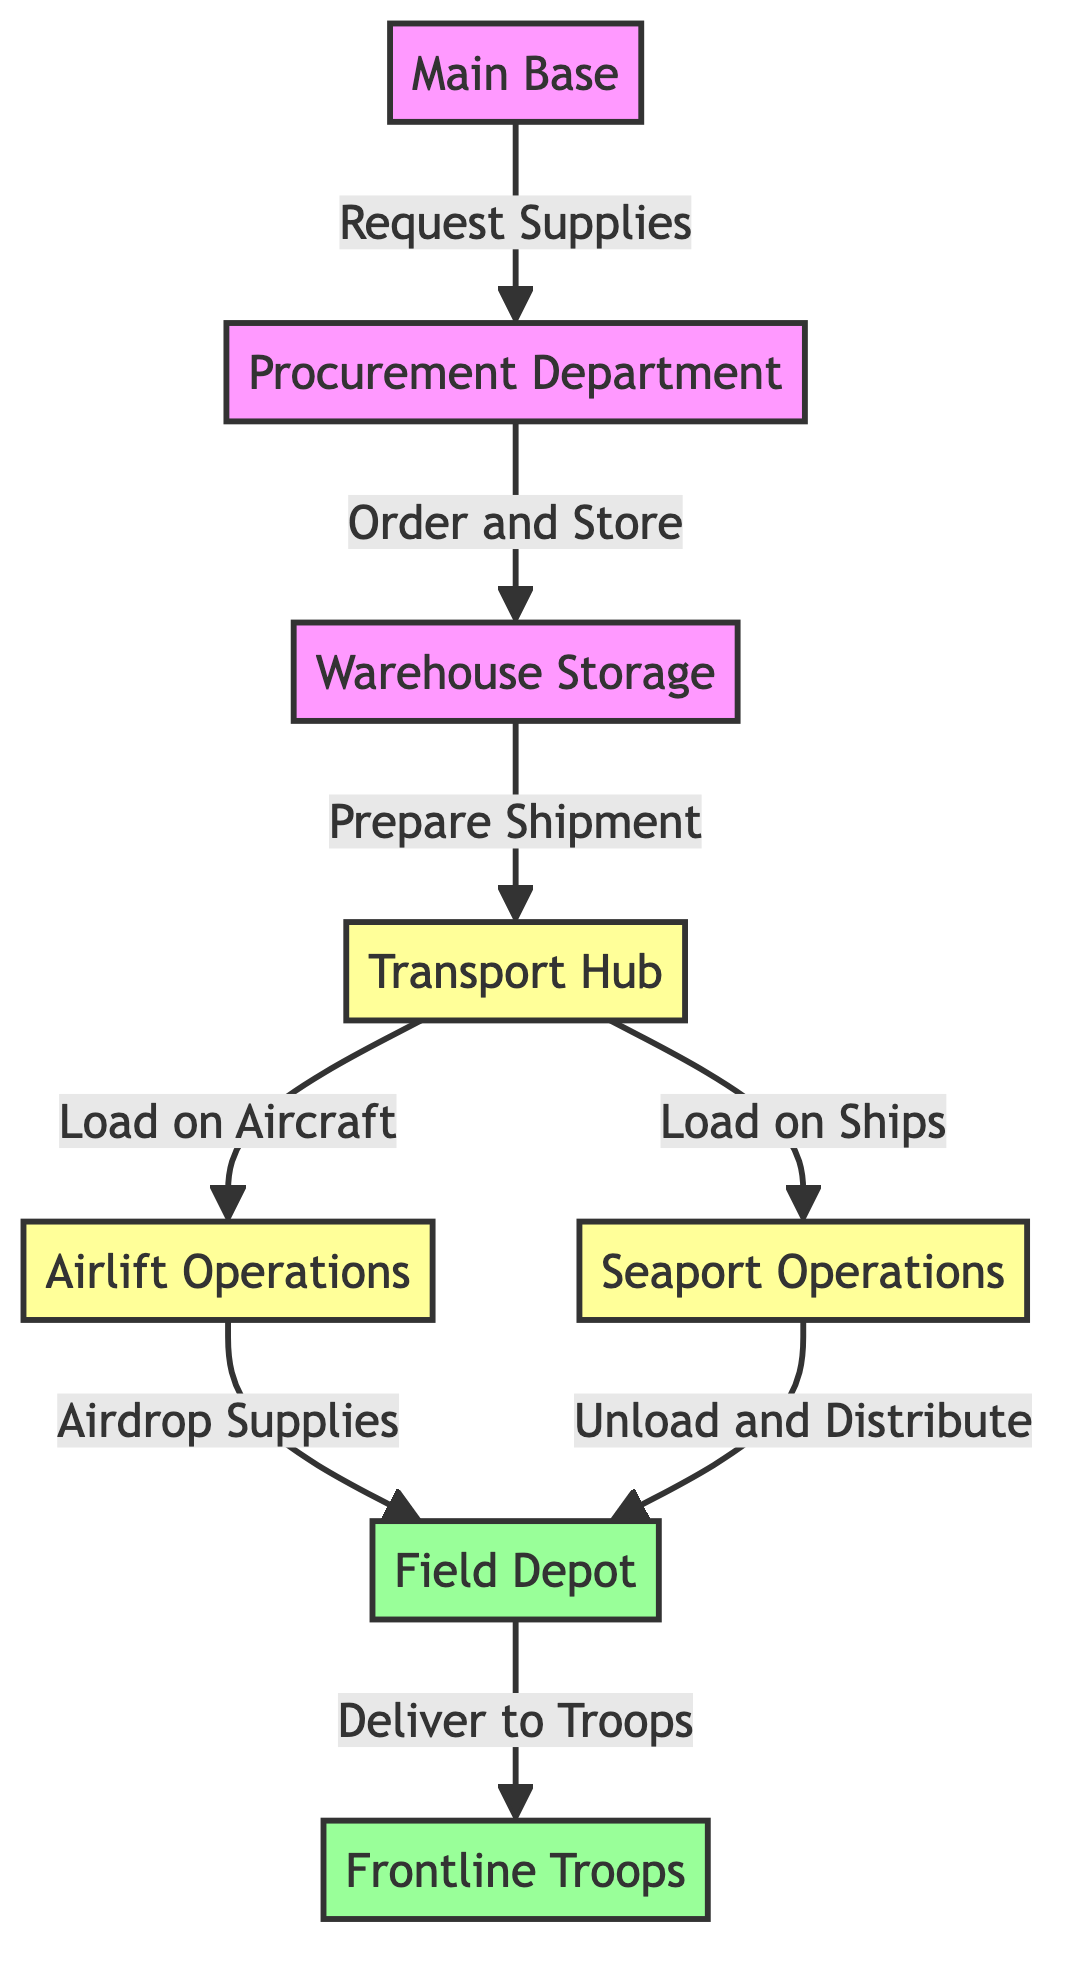What is the first node in the flowchart? The flowchart starts with the "Main Base" node, which is the initiating point for the supply chain and logistics.
Answer: Main Base How many nodes are present in the diagram? Counting all unique points in the flowchart, we identify the following nodes: Main Base, Procurement Department, Warehouse Storage, Transport Hub, Airlift Operations, Seaport Operations, Field Depot, and Frontline Troops, totaling eight nodes.
Answer: 8 Which node comes after "Warehouse Storage"? The next node in the flowchart following "Warehouse Storage" is "Transport Hub," as indicated by the directed arrow depicting the flow of the supply chain.
Answer: Transport Hub What action occurs between "Transport Hub" and "Airlift Operations"? The action depicted in the flowchart between "Transport Hub" and "Airlift Operations" is "Load on Aircraft," indicating the process of preparing for air transportation of supplies.
Answer: Load on Aircraft In which node do supplies get airdropped? The supplies are airdropped at the "Field Depot," which is the designated node for receiving supplies from airlift operations in the diagram.
Answer: Field Depot What two methods of transport are indicated in the diagram? The diagram illustrates two methods of transport: "Airlift Operations" and "Seaport Operations," representing aerial and maritime transport respectively.
Answer: Airlift Operations, Seaport Operations What is the final destination for supplies in the flowchart? The final destination where supplies are delivered is the "Frontline Troops," which is the last node in the flowchart indicating the end of the supply chain.
Answer: Frontline Troops How do supplies get to "Frontline Troops"? According to the diagram, supplies reach "Frontline Troops" after being delivered from the "Field Depot," which signifies a delivery step in the logistics process.
Answer: Deliver to Troops Which department handles the initial request for supplies? The "Procurement Department" is responsible for managing the initial requests for supplies as shown by the directed flow from "Main Base" to this department.
Answer: Procurement Department What happens at the "Seaport Operations" node? At the "Seaport Operations" node, the action performed is "Unload and Distribute," indicating the handling of supplies once they arrive by ship.
Answer: Unload and Distribute 